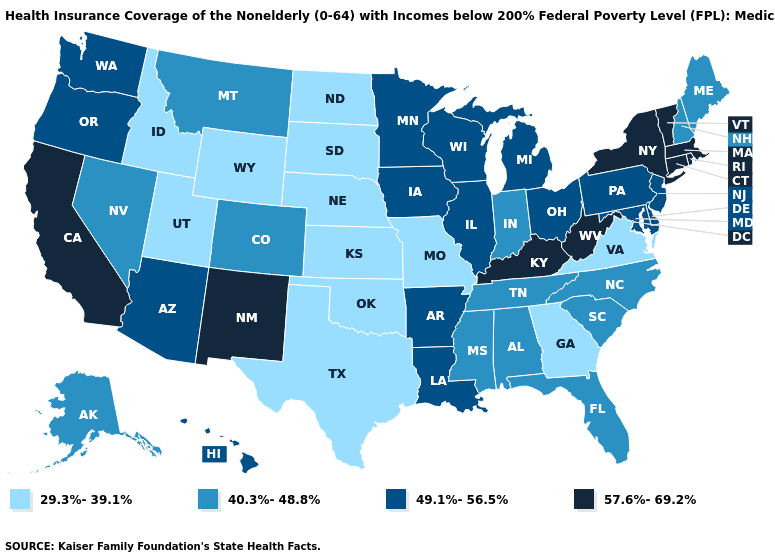Does Hawaii have the same value as Wyoming?
Keep it brief. No. Does the map have missing data?
Write a very short answer. No. What is the value of Florida?
Give a very brief answer. 40.3%-48.8%. Does Alabama have the same value as New Hampshire?
Quick response, please. Yes. Name the states that have a value in the range 49.1%-56.5%?
Concise answer only. Arizona, Arkansas, Delaware, Hawaii, Illinois, Iowa, Louisiana, Maryland, Michigan, Minnesota, New Jersey, Ohio, Oregon, Pennsylvania, Washington, Wisconsin. Which states hav the highest value in the Northeast?
Quick response, please. Connecticut, Massachusetts, New York, Rhode Island, Vermont. How many symbols are there in the legend?
Give a very brief answer. 4. Name the states that have a value in the range 40.3%-48.8%?
Give a very brief answer. Alabama, Alaska, Colorado, Florida, Indiana, Maine, Mississippi, Montana, Nevada, New Hampshire, North Carolina, South Carolina, Tennessee. Does California have the highest value in the West?
Be succinct. Yes. Name the states that have a value in the range 29.3%-39.1%?
Keep it brief. Georgia, Idaho, Kansas, Missouri, Nebraska, North Dakota, Oklahoma, South Dakota, Texas, Utah, Virginia, Wyoming. Which states have the lowest value in the USA?
Answer briefly. Georgia, Idaho, Kansas, Missouri, Nebraska, North Dakota, Oklahoma, South Dakota, Texas, Utah, Virginia, Wyoming. Which states have the highest value in the USA?
Keep it brief. California, Connecticut, Kentucky, Massachusetts, New Mexico, New York, Rhode Island, Vermont, West Virginia. Among the states that border Oregon , which have the highest value?
Quick response, please. California. Which states hav the highest value in the MidWest?
Answer briefly. Illinois, Iowa, Michigan, Minnesota, Ohio, Wisconsin. Does Kentucky have the highest value in the South?
Quick response, please. Yes. 